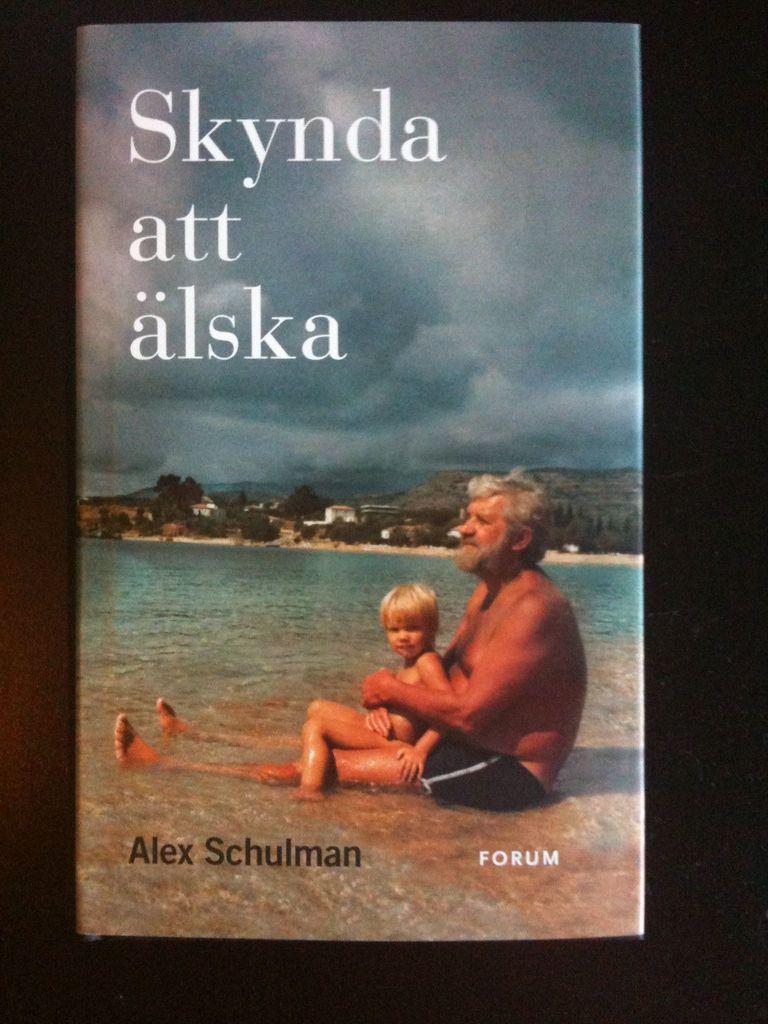What is the name of this book?
Provide a succinct answer. Skynda att alska. 